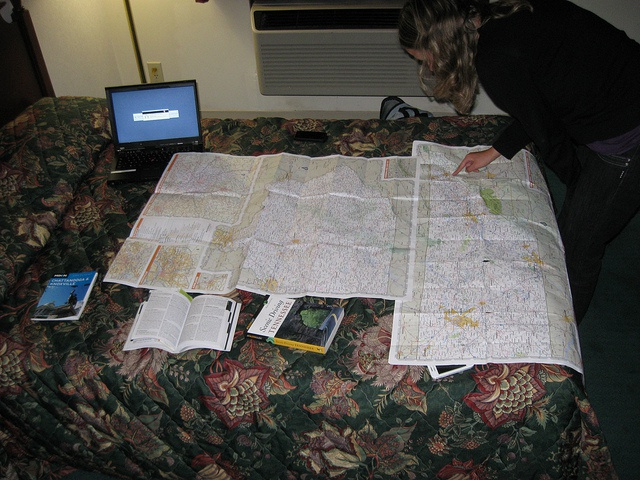Describe the objects in this image and their specific colors. I can see bed in black, gray, and maroon tones, people in black, gray, and maroon tones, bed in black, maroon, and gray tones, laptop in black, gray, and white tones, and book in black, darkgray, and lightgray tones in this image. 